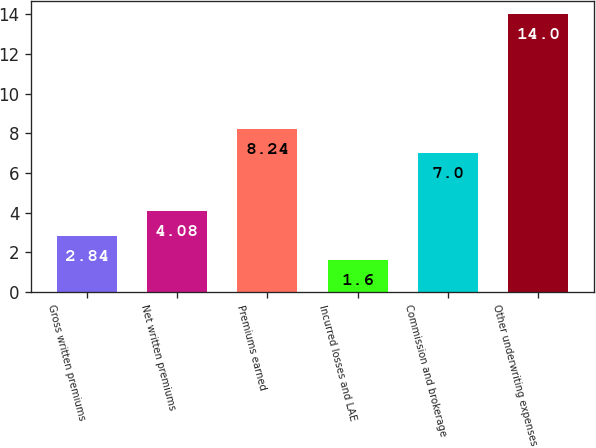Convert chart to OTSL. <chart><loc_0><loc_0><loc_500><loc_500><bar_chart><fcel>Gross written premiums<fcel>Net written premiums<fcel>Premiums earned<fcel>Incurred losses and LAE<fcel>Commission and brokerage<fcel>Other underwriting expenses<nl><fcel>2.84<fcel>4.08<fcel>8.24<fcel>1.6<fcel>7<fcel>14<nl></chart> 